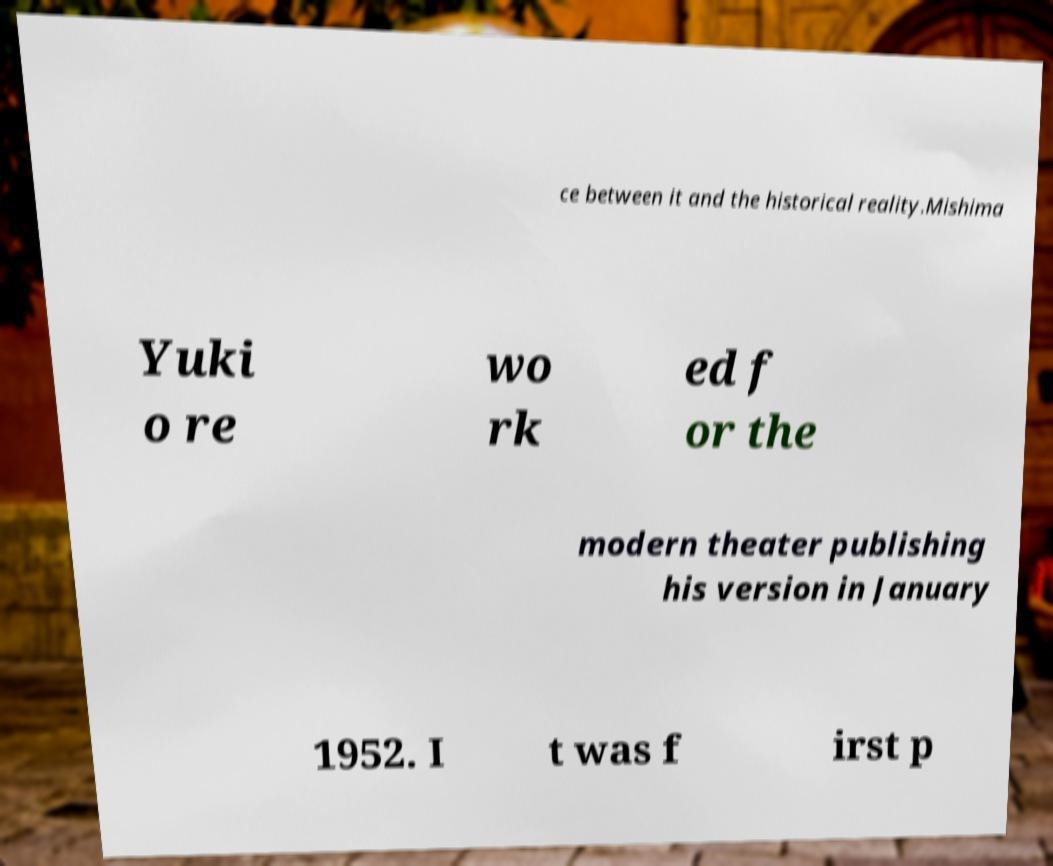Could you assist in decoding the text presented in this image and type it out clearly? ce between it and the historical reality.Mishima Yuki o re wo rk ed f or the modern theater publishing his version in January 1952. I t was f irst p 